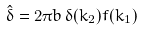Convert formula to latex. <formula><loc_0><loc_0><loc_500><loc_500>\hat { \delta } = 2 \pi b \, \delta ( k _ { 2 } ) f ( k _ { 1 } )</formula> 